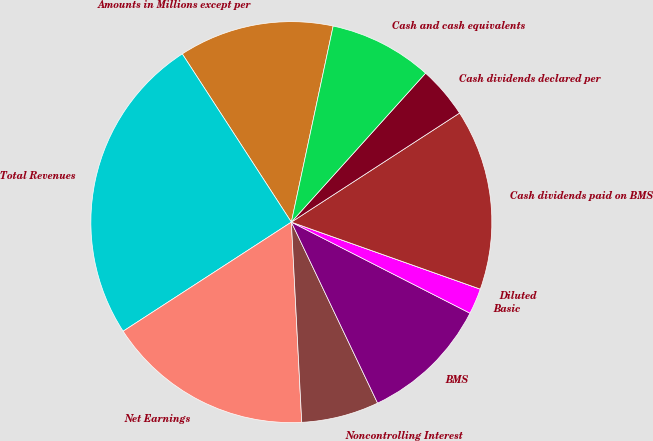<chart> <loc_0><loc_0><loc_500><loc_500><pie_chart><fcel>Amounts in Millions except per<fcel>Total Revenues<fcel>Net Earnings<fcel>Noncontrolling Interest<fcel>BMS<fcel>Basic<fcel>Diluted<fcel>Cash dividends paid on BMS<fcel>Cash dividends declared per<fcel>Cash and cash equivalents<nl><fcel>12.5%<fcel>25.0%<fcel>16.67%<fcel>6.25%<fcel>10.42%<fcel>2.08%<fcel>0.0%<fcel>14.58%<fcel>4.17%<fcel>8.33%<nl></chart> 